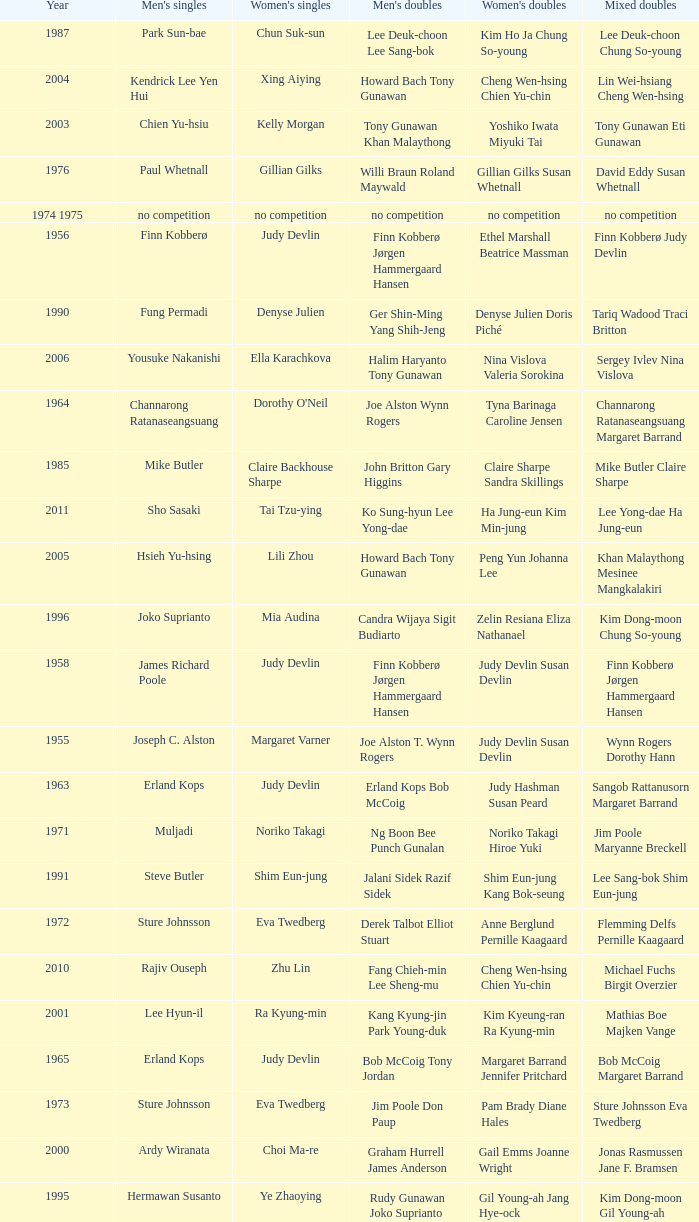Who were the men's doubles champions when the men's singles champion was muljadi? Ng Boon Bee Punch Gunalan. 